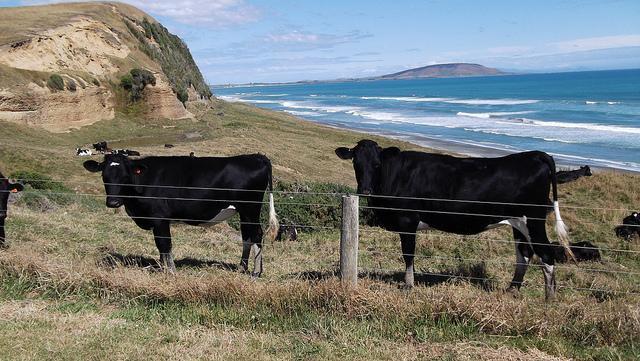How many fence posts do you see?
Give a very brief answer. 1. How many cows can be seen?
Give a very brief answer. 2. 